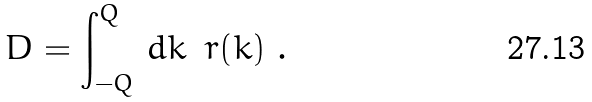<formula> <loc_0><loc_0><loc_500><loc_500>D = \int _ { - Q } ^ { Q } \, d k \, \ r ( k ) \ .</formula> 